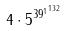<formula> <loc_0><loc_0><loc_500><loc_500>4 \cdot 5 ^ { { 3 9 ^ { 1 } } ^ { 1 3 2 } }</formula> 